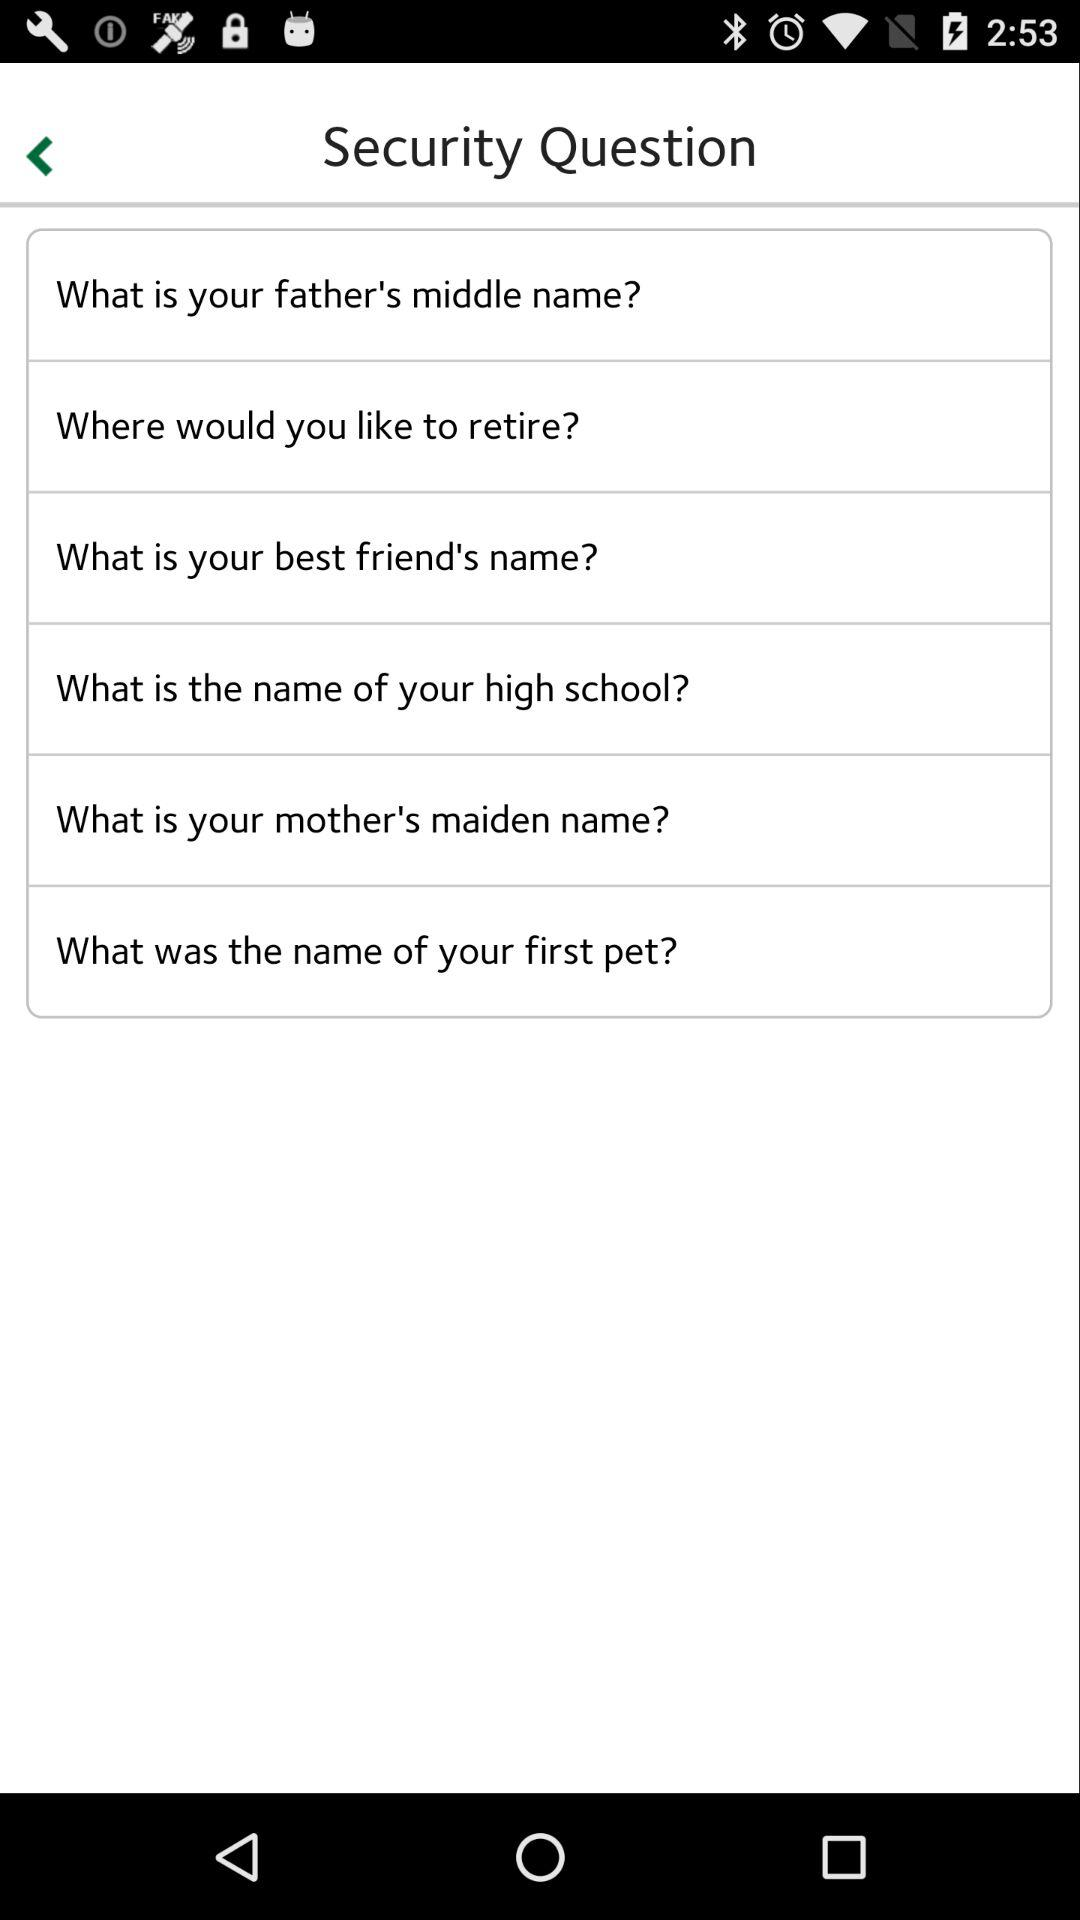How many security questions are there in total?
Answer the question using a single word or phrase. 6 